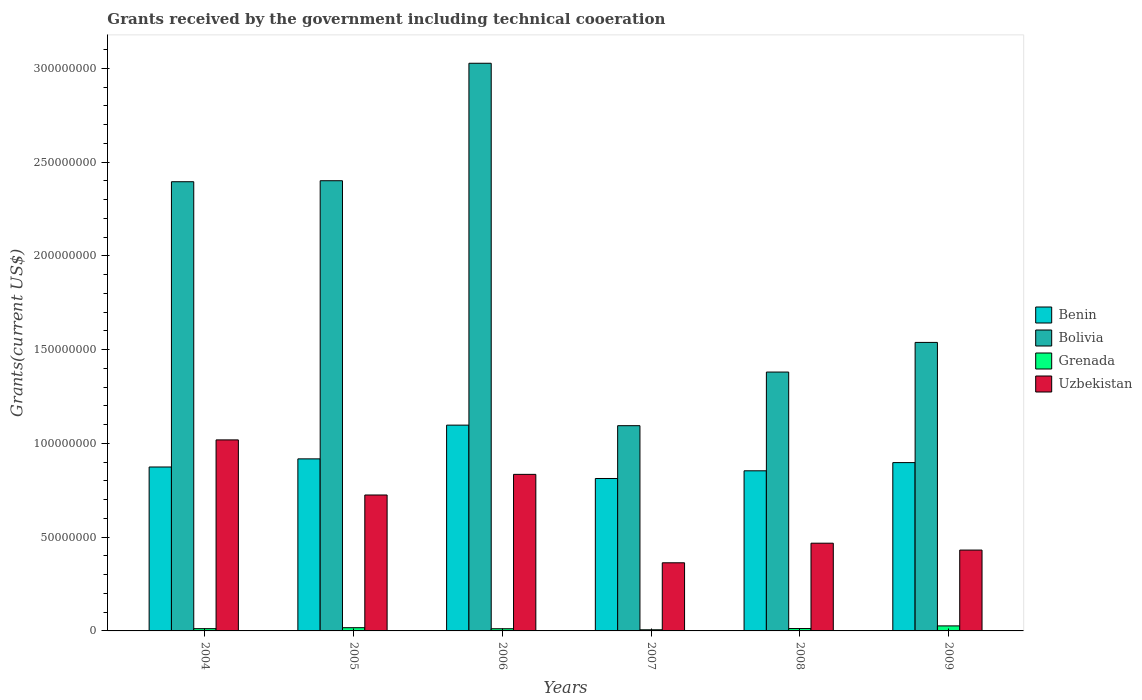Are the number of bars on each tick of the X-axis equal?
Make the answer very short. Yes. What is the label of the 6th group of bars from the left?
Provide a succinct answer. 2009. Across all years, what is the maximum total grants received by the government in Bolivia?
Keep it short and to the point. 3.03e+08. Across all years, what is the minimum total grants received by the government in Bolivia?
Your answer should be very brief. 1.09e+08. In which year was the total grants received by the government in Uzbekistan maximum?
Ensure brevity in your answer.  2004. What is the total total grants received by the government in Bolivia in the graph?
Make the answer very short. 1.18e+09. What is the difference between the total grants received by the government in Bolivia in 2004 and that in 2006?
Offer a very short reply. -6.32e+07. What is the difference between the total grants received by the government in Benin in 2007 and the total grants received by the government in Uzbekistan in 2004?
Your response must be concise. -2.06e+07. What is the average total grants received by the government in Benin per year?
Offer a very short reply. 9.09e+07. In the year 2006, what is the difference between the total grants received by the government in Benin and total grants received by the government in Uzbekistan?
Offer a terse response. 2.62e+07. What is the ratio of the total grants received by the government in Uzbekistan in 2004 to that in 2006?
Ensure brevity in your answer.  1.22. Is the difference between the total grants received by the government in Benin in 2005 and 2009 greater than the difference between the total grants received by the government in Uzbekistan in 2005 and 2009?
Give a very brief answer. No. What is the difference between the highest and the second highest total grants received by the government in Grenada?
Provide a short and direct response. 9.60e+05. What is the difference between the highest and the lowest total grants received by the government in Benin?
Offer a terse response. 2.84e+07. Is the sum of the total grants received by the government in Grenada in 2005 and 2008 greater than the maximum total grants received by the government in Benin across all years?
Keep it short and to the point. No. What does the 1st bar from the left in 2008 represents?
Your answer should be very brief. Benin. What does the 4th bar from the right in 2005 represents?
Offer a very short reply. Benin. Is it the case that in every year, the sum of the total grants received by the government in Uzbekistan and total grants received by the government in Bolivia is greater than the total grants received by the government in Benin?
Make the answer very short. Yes. Are all the bars in the graph horizontal?
Keep it short and to the point. No. Does the graph contain any zero values?
Offer a terse response. No. Does the graph contain grids?
Ensure brevity in your answer.  No. Where does the legend appear in the graph?
Your answer should be very brief. Center right. How are the legend labels stacked?
Offer a terse response. Vertical. What is the title of the graph?
Your answer should be very brief. Grants received by the government including technical cooeration. What is the label or title of the Y-axis?
Offer a very short reply. Grants(current US$). What is the Grants(current US$) of Benin in 2004?
Keep it short and to the point. 8.74e+07. What is the Grants(current US$) in Bolivia in 2004?
Your answer should be compact. 2.40e+08. What is the Grants(current US$) in Grenada in 2004?
Provide a succinct answer. 1.20e+06. What is the Grants(current US$) of Uzbekistan in 2004?
Offer a terse response. 1.02e+08. What is the Grants(current US$) of Benin in 2005?
Provide a succinct answer. 9.17e+07. What is the Grants(current US$) of Bolivia in 2005?
Provide a succinct answer. 2.40e+08. What is the Grants(current US$) of Grenada in 2005?
Your response must be concise. 1.72e+06. What is the Grants(current US$) of Uzbekistan in 2005?
Your answer should be compact. 7.25e+07. What is the Grants(current US$) of Benin in 2006?
Provide a succinct answer. 1.10e+08. What is the Grants(current US$) of Bolivia in 2006?
Your answer should be compact. 3.03e+08. What is the Grants(current US$) in Grenada in 2006?
Your response must be concise. 1.16e+06. What is the Grants(current US$) of Uzbekistan in 2006?
Offer a terse response. 8.35e+07. What is the Grants(current US$) of Benin in 2007?
Your response must be concise. 8.13e+07. What is the Grants(current US$) of Bolivia in 2007?
Your answer should be compact. 1.09e+08. What is the Grants(current US$) in Grenada in 2007?
Your answer should be compact. 6.00e+05. What is the Grants(current US$) in Uzbekistan in 2007?
Give a very brief answer. 3.63e+07. What is the Grants(current US$) of Benin in 2008?
Your response must be concise. 8.54e+07. What is the Grants(current US$) in Bolivia in 2008?
Offer a terse response. 1.38e+08. What is the Grants(current US$) of Grenada in 2008?
Your answer should be very brief. 1.27e+06. What is the Grants(current US$) of Uzbekistan in 2008?
Make the answer very short. 4.68e+07. What is the Grants(current US$) in Benin in 2009?
Your answer should be very brief. 8.98e+07. What is the Grants(current US$) of Bolivia in 2009?
Your answer should be very brief. 1.54e+08. What is the Grants(current US$) of Grenada in 2009?
Offer a very short reply. 2.68e+06. What is the Grants(current US$) in Uzbekistan in 2009?
Your answer should be compact. 4.31e+07. Across all years, what is the maximum Grants(current US$) in Benin?
Your answer should be very brief. 1.10e+08. Across all years, what is the maximum Grants(current US$) in Bolivia?
Keep it short and to the point. 3.03e+08. Across all years, what is the maximum Grants(current US$) of Grenada?
Provide a short and direct response. 2.68e+06. Across all years, what is the maximum Grants(current US$) of Uzbekistan?
Keep it short and to the point. 1.02e+08. Across all years, what is the minimum Grants(current US$) in Benin?
Provide a succinct answer. 8.13e+07. Across all years, what is the minimum Grants(current US$) of Bolivia?
Ensure brevity in your answer.  1.09e+08. Across all years, what is the minimum Grants(current US$) of Grenada?
Make the answer very short. 6.00e+05. Across all years, what is the minimum Grants(current US$) in Uzbekistan?
Give a very brief answer. 3.63e+07. What is the total Grants(current US$) of Benin in the graph?
Make the answer very short. 5.45e+08. What is the total Grants(current US$) in Bolivia in the graph?
Provide a succinct answer. 1.18e+09. What is the total Grants(current US$) of Grenada in the graph?
Your answer should be very brief. 8.63e+06. What is the total Grants(current US$) in Uzbekistan in the graph?
Give a very brief answer. 3.84e+08. What is the difference between the Grants(current US$) of Benin in 2004 and that in 2005?
Give a very brief answer. -4.33e+06. What is the difference between the Grants(current US$) of Bolivia in 2004 and that in 2005?
Provide a short and direct response. -5.30e+05. What is the difference between the Grants(current US$) in Grenada in 2004 and that in 2005?
Give a very brief answer. -5.20e+05. What is the difference between the Grants(current US$) in Uzbekistan in 2004 and that in 2005?
Keep it short and to the point. 2.94e+07. What is the difference between the Grants(current US$) in Benin in 2004 and that in 2006?
Offer a terse response. -2.23e+07. What is the difference between the Grants(current US$) in Bolivia in 2004 and that in 2006?
Provide a short and direct response. -6.32e+07. What is the difference between the Grants(current US$) of Grenada in 2004 and that in 2006?
Offer a very short reply. 4.00e+04. What is the difference between the Grants(current US$) of Uzbekistan in 2004 and that in 2006?
Your answer should be very brief. 1.84e+07. What is the difference between the Grants(current US$) of Benin in 2004 and that in 2007?
Make the answer very short. 6.13e+06. What is the difference between the Grants(current US$) in Bolivia in 2004 and that in 2007?
Provide a succinct answer. 1.30e+08. What is the difference between the Grants(current US$) of Uzbekistan in 2004 and that in 2007?
Keep it short and to the point. 6.55e+07. What is the difference between the Grants(current US$) of Benin in 2004 and that in 2008?
Your answer should be compact. 2.03e+06. What is the difference between the Grants(current US$) of Bolivia in 2004 and that in 2008?
Make the answer very short. 1.01e+08. What is the difference between the Grants(current US$) of Grenada in 2004 and that in 2008?
Keep it short and to the point. -7.00e+04. What is the difference between the Grants(current US$) of Uzbekistan in 2004 and that in 2008?
Offer a very short reply. 5.51e+07. What is the difference between the Grants(current US$) in Benin in 2004 and that in 2009?
Provide a short and direct response. -2.34e+06. What is the difference between the Grants(current US$) in Bolivia in 2004 and that in 2009?
Provide a short and direct response. 8.57e+07. What is the difference between the Grants(current US$) of Grenada in 2004 and that in 2009?
Offer a very short reply. -1.48e+06. What is the difference between the Grants(current US$) of Uzbekistan in 2004 and that in 2009?
Ensure brevity in your answer.  5.88e+07. What is the difference between the Grants(current US$) of Benin in 2005 and that in 2006?
Make the answer very short. -1.80e+07. What is the difference between the Grants(current US$) in Bolivia in 2005 and that in 2006?
Provide a succinct answer. -6.26e+07. What is the difference between the Grants(current US$) of Grenada in 2005 and that in 2006?
Give a very brief answer. 5.60e+05. What is the difference between the Grants(current US$) of Uzbekistan in 2005 and that in 2006?
Provide a succinct answer. -1.10e+07. What is the difference between the Grants(current US$) in Benin in 2005 and that in 2007?
Provide a succinct answer. 1.05e+07. What is the difference between the Grants(current US$) in Bolivia in 2005 and that in 2007?
Your answer should be compact. 1.31e+08. What is the difference between the Grants(current US$) in Grenada in 2005 and that in 2007?
Keep it short and to the point. 1.12e+06. What is the difference between the Grants(current US$) in Uzbekistan in 2005 and that in 2007?
Make the answer very short. 3.62e+07. What is the difference between the Grants(current US$) in Benin in 2005 and that in 2008?
Offer a terse response. 6.36e+06. What is the difference between the Grants(current US$) of Bolivia in 2005 and that in 2008?
Make the answer very short. 1.02e+08. What is the difference between the Grants(current US$) of Grenada in 2005 and that in 2008?
Ensure brevity in your answer.  4.50e+05. What is the difference between the Grants(current US$) of Uzbekistan in 2005 and that in 2008?
Provide a short and direct response. 2.57e+07. What is the difference between the Grants(current US$) in Benin in 2005 and that in 2009?
Offer a terse response. 1.99e+06. What is the difference between the Grants(current US$) of Bolivia in 2005 and that in 2009?
Give a very brief answer. 8.62e+07. What is the difference between the Grants(current US$) in Grenada in 2005 and that in 2009?
Your answer should be very brief. -9.60e+05. What is the difference between the Grants(current US$) of Uzbekistan in 2005 and that in 2009?
Your answer should be compact. 2.94e+07. What is the difference between the Grants(current US$) in Benin in 2006 and that in 2007?
Ensure brevity in your answer.  2.84e+07. What is the difference between the Grants(current US$) of Bolivia in 2006 and that in 2007?
Offer a very short reply. 1.93e+08. What is the difference between the Grants(current US$) of Grenada in 2006 and that in 2007?
Your response must be concise. 5.60e+05. What is the difference between the Grants(current US$) of Uzbekistan in 2006 and that in 2007?
Give a very brief answer. 4.72e+07. What is the difference between the Grants(current US$) of Benin in 2006 and that in 2008?
Provide a short and direct response. 2.44e+07. What is the difference between the Grants(current US$) in Bolivia in 2006 and that in 2008?
Offer a very short reply. 1.65e+08. What is the difference between the Grants(current US$) of Uzbekistan in 2006 and that in 2008?
Your response must be concise. 3.67e+07. What is the difference between the Grants(current US$) in Benin in 2006 and that in 2009?
Your response must be concise. 2.00e+07. What is the difference between the Grants(current US$) of Bolivia in 2006 and that in 2009?
Ensure brevity in your answer.  1.49e+08. What is the difference between the Grants(current US$) in Grenada in 2006 and that in 2009?
Give a very brief answer. -1.52e+06. What is the difference between the Grants(current US$) in Uzbekistan in 2006 and that in 2009?
Give a very brief answer. 4.04e+07. What is the difference between the Grants(current US$) of Benin in 2007 and that in 2008?
Your response must be concise. -4.10e+06. What is the difference between the Grants(current US$) of Bolivia in 2007 and that in 2008?
Offer a very short reply. -2.86e+07. What is the difference between the Grants(current US$) of Grenada in 2007 and that in 2008?
Your answer should be very brief. -6.70e+05. What is the difference between the Grants(current US$) of Uzbekistan in 2007 and that in 2008?
Offer a terse response. -1.04e+07. What is the difference between the Grants(current US$) in Benin in 2007 and that in 2009?
Provide a short and direct response. -8.47e+06. What is the difference between the Grants(current US$) of Bolivia in 2007 and that in 2009?
Keep it short and to the point. -4.44e+07. What is the difference between the Grants(current US$) in Grenada in 2007 and that in 2009?
Offer a very short reply. -2.08e+06. What is the difference between the Grants(current US$) in Uzbekistan in 2007 and that in 2009?
Your response must be concise. -6.78e+06. What is the difference between the Grants(current US$) in Benin in 2008 and that in 2009?
Provide a short and direct response. -4.37e+06. What is the difference between the Grants(current US$) of Bolivia in 2008 and that in 2009?
Offer a very short reply. -1.58e+07. What is the difference between the Grants(current US$) of Grenada in 2008 and that in 2009?
Your answer should be very brief. -1.41e+06. What is the difference between the Grants(current US$) of Uzbekistan in 2008 and that in 2009?
Offer a terse response. 3.67e+06. What is the difference between the Grants(current US$) in Benin in 2004 and the Grants(current US$) in Bolivia in 2005?
Ensure brevity in your answer.  -1.53e+08. What is the difference between the Grants(current US$) in Benin in 2004 and the Grants(current US$) in Grenada in 2005?
Keep it short and to the point. 8.57e+07. What is the difference between the Grants(current US$) of Benin in 2004 and the Grants(current US$) of Uzbekistan in 2005?
Offer a terse response. 1.49e+07. What is the difference between the Grants(current US$) in Bolivia in 2004 and the Grants(current US$) in Grenada in 2005?
Your answer should be very brief. 2.38e+08. What is the difference between the Grants(current US$) of Bolivia in 2004 and the Grants(current US$) of Uzbekistan in 2005?
Provide a succinct answer. 1.67e+08. What is the difference between the Grants(current US$) of Grenada in 2004 and the Grants(current US$) of Uzbekistan in 2005?
Your answer should be very brief. -7.13e+07. What is the difference between the Grants(current US$) in Benin in 2004 and the Grants(current US$) in Bolivia in 2006?
Ensure brevity in your answer.  -2.15e+08. What is the difference between the Grants(current US$) in Benin in 2004 and the Grants(current US$) in Grenada in 2006?
Provide a succinct answer. 8.62e+07. What is the difference between the Grants(current US$) of Benin in 2004 and the Grants(current US$) of Uzbekistan in 2006?
Offer a very short reply. 3.93e+06. What is the difference between the Grants(current US$) in Bolivia in 2004 and the Grants(current US$) in Grenada in 2006?
Offer a terse response. 2.38e+08. What is the difference between the Grants(current US$) of Bolivia in 2004 and the Grants(current US$) of Uzbekistan in 2006?
Provide a short and direct response. 1.56e+08. What is the difference between the Grants(current US$) in Grenada in 2004 and the Grants(current US$) in Uzbekistan in 2006?
Your answer should be very brief. -8.23e+07. What is the difference between the Grants(current US$) in Benin in 2004 and the Grants(current US$) in Bolivia in 2007?
Your response must be concise. -2.20e+07. What is the difference between the Grants(current US$) of Benin in 2004 and the Grants(current US$) of Grenada in 2007?
Offer a terse response. 8.68e+07. What is the difference between the Grants(current US$) in Benin in 2004 and the Grants(current US$) in Uzbekistan in 2007?
Give a very brief answer. 5.11e+07. What is the difference between the Grants(current US$) of Bolivia in 2004 and the Grants(current US$) of Grenada in 2007?
Your answer should be very brief. 2.39e+08. What is the difference between the Grants(current US$) of Bolivia in 2004 and the Grants(current US$) of Uzbekistan in 2007?
Provide a succinct answer. 2.03e+08. What is the difference between the Grants(current US$) in Grenada in 2004 and the Grants(current US$) in Uzbekistan in 2007?
Your response must be concise. -3.51e+07. What is the difference between the Grants(current US$) in Benin in 2004 and the Grants(current US$) in Bolivia in 2008?
Offer a very short reply. -5.06e+07. What is the difference between the Grants(current US$) in Benin in 2004 and the Grants(current US$) in Grenada in 2008?
Make the answer very short. 8.61e+07. What is the difference between the Grants(current US$) in Benin in 2004 and the Grants(current US$) in Uzbekistan in 2008?
Offer a terse response. 4.06e+07. What is the difference between the Grants(current US$) of Bolivia in 2004 and the Grants(current US$) of Grenada in 2008?
Your response must be concise. 2.38e+08. What is the difference between the Grants(current US$) of Bolivia in 2004 and the Grants(current US$) of Uzbekistan in 2008?
Provide a succinct answer. 1.93e+08. What is the difference between the Grants(current US$) of Grenada in 2004 and the Grants(current US$) of Uzbekistan in 2008?
Offer a very short reply. -4.56e+07. What is the difference between the Grants(current US$) of Benin in 2004 and the Grants(current US$) of Bolivia in 2009?
Offer a terse response. -6.64e+07. What is the difference between the Grants(current US$) in Benin in 2004 and the Grants(current US$) in Grenada in 2009?
Your response must be concise. 8.47e+07. What is the difference between the Grants(current US$) in Benin in 2004 and the Grants(current US$) in Uzbekistan in 2009?
Provide a short and direct response. 4.43e+07. What is the difference between the Grants(current US$) in Bolivia in 2004 and the Grants(current US$) in Grenada in 2009?
Provide a short and direct response. 2.37e+08. What is the difference between the Grants(current US$) of Bolivia in 2004 and the Grants(current US$) of Uzbekistan in 2009?
Your answer should be very brief. 1.96e+08. What is the difference between the Grants(current US$) in Grenada in 2004 and the Grants(current US$) in Uzbekistan in 2009?
Provide a short and direct response. -4.19e+07. What is the difference between the Grants(current US$) of Benin in 2005 and the Grants(current US$) of Bolivia in 2006?
Your response must be concise. -2.11e+08. What is the difference between the Grants(current US$) of Benin in 2005 and the Grants(current US$) of Grenada in 2006?
Keep it short and to the point. 9.06e+07. What is the difference between the Grants(current US$) of Benin in 2005 and the Grants(current US$) of Uzbekistan in 2006?
Ensure brevity in your answer.  8.26e+06. What is the difference between the Grants(current US$) in Bolivia in 2005 and the Grants(current US$) in Grenada in 2006?
Keep it short and to the point. 2.39e+08. What is the difference between the Grants(current US$) of Bolivia in 2005 and the Grants(current US$) of Uzbekistan in 2006?
Your response must be concise. 1.57e+08. What is the difference between the Grants(current US$) of Grenada in 2005 and the Grants(current US$) of Uzbekistan in 2006?
Keep it short and to the point. -8.18e+07. What is the difference between the Grants(current US$) of Benin in 2005 and the Grants(current US$) of Bolivia in 2007?
Offer a terse response. -1.77e+07. What is the difference between the Grants(current US$) of Benin in 2005 and the Grants(current US$) of Grenada in 2007?
Make the answer very short. 9.11e+07. What is the difference between the Grants(current US$) in Benin in 2005 and the Grants(current US$) in Uzbekistan in 2007?
Ensure brevity in your answer.  5.54e+07. What is the difference between the Grants(current US$) of Bolivia in 2005 and the Grants(current US$) of Grenada in 2007?
Your answer should be very brief. 2.39e+08. What is the difference between the Grants(current US$) in Bolivia in 2005 and the Grants(current US$) in Uzbekistan in 2007?
Make the answer very short. 2.04e+08. What is the difference between the Grants(current US$) of Grenada in 2005 and the Grants(current US$) of Uzbekistan in 2007?
Your response must be concise. -3.46e+07. What is the difference between the Grants(current US$) in Benin in 2005 and the Grants(current US$) in Bolivia in 2008?
Ensure brevity in your answer.  -4.63e+07. What is the difference between the Grants(current US$) in Benin in 2005 and the Grants(current US$) in Grenada in 2008?
Offer a terse response. 9.05e+07. What is the difference between the Grants(current US$) of Benin in 2005 and the Grants(current US$) of Uzbekistan in 2008?
Give a very brief answer. 4.50e+07. What is the difference between the Grants(current US$) in Bolivia in 2005 and the Grants(current US$) in Grenada in 2008?
Your answer should be compact. 2.39e+08. What is the difference between the Grants(current US$) of Bolivia in 2005 and the Grants(current US$) of Uzbekistan in 2008?
Your answer should be compact. 1.93e+08. What is the difference between the Grants(current US$) of Grenada in 2005 and the Grants(current US$) of Uzbekistan in 2008?
Your answer should be compact. -4.51e+07. What is the difference between the Grants(current US$) of Benin in 2005 and the Grants(current US$) of Bolivia in 2009?
Offer a very short reply. -6.21e+07. What is the difference between the Grants(current US$) of Benin in 2005 and the Grants(current US$) of Grenada in 2009?
Provide a succinct answer. 8.91e+07. What is the difference between the Grants(current US$) of Benin in 2005 and the Grants(current US$) of Uzbekistan in 2009?
Keep it short and to the point. 4.86e+07. What is the difference between the Grants(current US$) in Bolivia in 2005 and the Grants(current US$) in Grenada in 2009?
Your answer should be very brief. 2.37e+08. What is the difference between the Grants(current US$) in Bolivia in 2005 and the Grants(current US$) in Uzbekistan in 2009?
Ensure brevity in your answer.  1.97e+08. What is the difference between the Grants(current US$) of Grenada in 2005 and the Grants(current US$) of Uzbekistan in 2009?
Provide a succinct answer. -4.14e+07. What is the difference between the Grants(current US$) in Benin in 2006 and the Grants(current US$) in Bolivia in 2007?
Your answer should be very brief. 2.90e+05. What is the difference between the Grants(current US$) of Benin in 2006 and the Grants(current US$) of Grenada in 2007?
Offer a terse response. 1.09e+08. What is the difference between the Grants(current US$) in Benin in 2006 and the Grants(current US$) in Uzbekistan in 2007?
Your response must be concise. 7.34e+07. What is the difference between the Grants(current US$) of Bolivia in 2006 and the Grants(current US$) of Grenada in 2007?
Your answer should be compact. 3.02e+08. What is the difference between the Grants(current US$) of Bolivia in 2006 and the Grants(current US$) of Uzbekistan in 2007?
Ensure brevity in your answer.  2.66e+08. What is the difference between the Grants(current US$) of Grenada in 2006 and the Grants(current US$) of Uzbekistan in 2007?
Offer a terse response. -3.52e+07. What is the difference between the Grants(current US$) of Benin in 2006 and the Grants(current US$) of Bolivia in 2008?
Provide a succinct answer. -2.83e+07. What is the difference between the Grants(current US$) of Benin in 2006 and the Grants(current US$) of Grenada in 2008?
Make the answer very short. 1.08e+08. What is the difference between the Grants(current US$) in Benin in 2006 and the Grants(current US$) in Uzbekistan in 2008?
Give a very brief answer. 6.30e+07. What is the difference between the Grants(current US$) of Bolivia in 2006 and the Grants(current US$) of Grenada in 2008?
Your answer should be very brief. 3.01e+08. What is the difference between the Grants(current US$) in Bolivia in 2006 and the Grants(current US$) in Uzbekistan in 2008?
Provide a short and direct response. 2.56e+08. What is the difference between the Grants(current US$) in Grenada in 2006 and the Grants(current US$) in Uzbekistan in 2008?
Provide a short and direct response. -4.56e+07. What is the difference between the Grants(current US$) of Benin in 2006 and the Grants(current US$) of Bolivia in 2009?
Your response must be concise. -4.41e+07. What is the difference between the Grants(current US$) of Benin in 2006 and the Grants(current US$) of Grenada in 2009?
Keep it short and to the point. 1.07e+08. What is the difference between the Grants(current US$) of Benin in 2006 and the Grants(current US$) of Uzbekistan in 2009?
Your answer should be very brief. 6.66e+07. What is the difference between the Grants(current US$) of Bolivia in 2006 and the Grants(current US$) of Grenada in 2009?
Offer a very short reply. 3.00e+08. What is the difference between the Grants(current US$) in Bolivia in 2006 and the Grants(current US$) in Uzbekistan in 2009?
Make the answer very short. 2.60e+08. What is the difference between the Grants(current US$) in Grenada in 2006 and the Grants(current US$) in Uzbekistan in 2009?
Give a very brief answer. -4.20e+07. What is the difference between the Grants(current US$) of Benin in 2007 and the Grants(current US$) of Bolivia in 2008?
Your response must be concise. -5.68e+07. What is the difference between the Grants(current US$) in Benin in 2007 and the Grants(current US$) in Grenada in 2008?
Your answer should be very brief. 8.00e+07. What is the difference between the Grants(current US$) in Benin in 2007 and the Grants(current US$) in Uzbekistan in 2008?
Make the answer very short. 3.45e+07. What is the difference between the Grants(current US$) in Bolivia in 2007 and the Grants(current US$) in Grenada in 2008?
Make the answer very short. 1.08e+08. What is the difference between the Grants(current US$) in Bolivia in 2007 and the Grants(current US$) in Uzbekistan in 2008?
Keep it short and to the point. 6.27e+07. What is the difference between the Grants(current US$) in Grenada in 2007 and the Grants(current US$) in Uzbekistan in 2008?
Provide a short and direct response. -4.62e+07. What is the difference between the Grants(current US$) of Benin in 2007 and the Grants(current US$) of Bolivia in 2009?
Offer a very short reply. -7.26e+07. What is the difference between the Grants(current US$) in Benin in 2007 and the Grants(current US$) in Grenada in 2009?
Keep it short and to the point. 7.86e+07. What is the difference between the Grants(current US$) in Benin in 2007 and the Grants(current US$) in Uzbekistan in 2009?
Offer a very short reply. 3.82e+07. What is the difference between the Grants(current US$) of Bolivia in 2007 and the Grants(current US$) of Grenada in 2009?
Your response must be concise. 1.07e+08. What is the difference between the Grants(current US$) of Bolivia in 2007 and the Grants(current US$) of Uzbekistan in 2009?
Keep it short and to the point. 6.63e+07. What is the difference between the Grants(current US$) of Grenada in 2007 and the Grants(current US$) of Uzbekistan in 2009?
Your answer should be compact. -4.25e+07. What is the difference between the Grants(current US$) in Benin in 2008 and the Grants(current US$) in Bolivia in 2009?
Your answer should be compact. -6.85e+07. What is the difference between the Grants(current US$) in Benin in 2008 and the Grants(current US$) in Grenada in 2009?
Provide a succinct answer. 8.27e+07. What is the difference between the Grants(current US$) of Benin in 2008 and the Grants(current US$) of Uzbekistan in 2009?
Keep it short and to the point. 4.23e+07. What is the difference between the Grants(current US$) in Bolivia in 2008 and the Grants(current US$) in Grenada in 2009?
Offer a terse response. 1.35e+08. What is the difference between the Grants(current US$) of Bolivia in 2008 and the Grants(current US$) of Uzbekistan in 2009?
Make the answer very short. 9.49e+07. What is the difference between the Grants(current US$) in Grenada in 2008 and the Grants(current US$) in Uzbekistan in 2009?
Your answer should be compact. -4.18e+07. What is the average Grants(current US$) in Benin per year?
Keep it short and to the point. 9.09e+07. What is the average Grants(current US$) in Bolivia per year?
Your response must be concise. 1.97e+08. What is the average Grants(current US$) in Grenada per year?
Your response must be concise. 1.44e+06. What is the average Grants(current US$) in Uzbekistan per year?
Ensure brevity in your answer.  6.40e+07. In the year 2004, what is the difference between the Grants(current US$) in Benin and Grants(current US$) in Bolivia?
Your answer should be very brief. -1.52e+08. In the year 2004, what is the difference between the Grants(current US$) of Benin and Grants(current US$) of Grenada?
Keep it short and to the point. 8.62e+07. In the year 2004, what is the difference between the Grants(current US$) of Benin and Grants(current US$) of Uzbekistan?
Provide a short and direct response. -1.44e+07. In the year 2004, what is the difference between the Grants(current US$) of Bolivia and Grants(current US$) of Grenada?
Ensure brevity in your answer.  2.38e+08. In the year 2004, what is the difference between the Grants(current US$) of Bolivia and Grants(current US$) of Uzbekistan?
Provide a succinct answer. 1.38e+08. In the year 2004, what is the difference between the Grants(current US$) in Grenada and Grants(current US$) in Uzbekistan?
Give a very brief answer. -1.01e+08. In the year 2005, what is the difference between the Grants(current US$) of Benin and Grants(current US$) of Bolivia?
Offer a terse response. -1.48e+08. In the year 2005, what is the difference between the Grants(current US$) of Benin and Grants(current US$) of Grenada?
Offer a terse response. 9.00e+07. In the year 2005, what is the difference between the Grants(current US$) in Benin and Grants(current US$) in Uzbekistan?
Provide a short and direct response. 1.93e+07. In the year 2005, what is the difference between the Grants(current US$) of Bolivia and Grants(current US$) of Grenada?
Ensure brevity in your answer.  2.38e+08. In the year 2005, what is the difference between the Grants(current US$) of Bolivia and Grants(current US$) of Uzbekistan?
Provide a succinct answer. 1.68e+08. In the year 2005, what is the difference between the Grants(current US$) of Grenada and Grants(current US$) of Uzbekistan?
Your answer should be very brief. -7.08e+07. In the year 2006, what is the difference between the Grants(current US$) in Benin and Grants(current US$) in Bolivia?
Provide a short and direct response. -1.93e+08. In the year 2006, what is the difference between the Grants(current US$) of Benin and Grants(current US$) of Grenada?
Offer a very short reply. 1.09e+08. In the year 2006, what is the difference between the Grants(current US$) in Benin and Grants(current US$) in Uzbekistan?
Give a very brief answer. 2.62e+07. In the year 2006, what is the difference between the Grants(current US$) in Bolivia and Grants(current US$) in Grenada?
Offer a very short reply. 3.02e+08. In the year 2006, what is the difference between the Grants(current US$) of Bolivia and Grants(current US$) of Uzbekistan?
Your response must be concise. 2.19e+08. In the year 2006, what is the difference between the Grants(current US$) in Grenada and Grants(current US$) in Uzbekistan?
Provide a short and direct response. -8.23e+07. In the year 2007, what is the difference between the Grants(current US$) of Benin and Grants(current US$) of Bolivia?
Offer a terse response. -2.82e+07. In the year 2007, what is the difference between the Grants(current US$) of Benin and Grants(current US$) of Grenada?
Keep it short and to the point. 8.07e+07. In the year 2007, what is the difference between the Grants(current US$) in Benin and Grants(current US$) in Uzbekistan?
Keep it short and to the point. 4.50e+07. In the year 2007, what is the difference between the Grants(current US$) in Bolivia and Grants(current US$) in Grenada?
Your response must be concise. 1.09e+08. In the year 2007, what is the difference between the Grants(current US$) in Bolivia and Grants(current US$) in Uzbekistan?
Provide a succinct answer. 7.31e+07. In the year 2007, what is the difference between the Grants(current US$) in Grenada and Grants(current US$) in Uzbekistan?
Provide a short and direct response. -3.57e+07. In the year 2008, what is the difference between the Grants(current US$) in Benin and Grants(current US$) in Bolivia?
Give a very brief answer. -5.26e+07. In the year 2008, what is the difference between the Grants(current US$) of Benin and Grants(current US$) of Grenada?
Provide a short and direct response. 8.41e+07. In the year 2008, what is the difference between the Grants(current US$) of Benin and Grants(current US$) of Uzbekistan?
Provide a short and direct response. 3.86e+07. In the year 2008, what is the difference between the Grants(current US$) of Bolivia and Grants(current US$) of Grenada?
Your answer should be very brief. 1.37e+08. In the year 2008, what is the difference between the Grants(current US$) in Bolivia and Grants(current US$) in Uzbekistan?
Provide a short and direct response. 9.12e+07. In the year 2008, what is the difference between the Grants(current US$) of Grenada and Grants(current US$) of Uzbekistan?
Provide a short and direct response. -4.55e+07. In the year 2009, what is the difference between the Grants(current US$) of Benin and Grants(current US$) of Bolivia?
Keep it short and to the point. -6.41e+07. In the year 2009, what is the difference between the Grants(current US$) of Benin and Grants(current US$) of Grenada?
Offer a very short reply. 8.71e+07. In the year 2009, what is the difference between the Grants(current US$) in Benin and Grants(current US$) in Uzbekistan?
Offer a terse response. 4.66e+07. In the year 2009, what is the difference between the Grants(current US$) in Bolivia and Grants(current US$) in Grenada?
Provide a short and direct response. 1.51e+08. In the year 2009, what is the difference between the Grants(current US$) in Bolivia and Grants(current US$) in Uzbekistan?
Give a very brief answer. 1.11e+08. In the year 2009, what is the difference between the Grants(current US$) in Grenada and Grants(current US$) in Uzbekistan?
Offer a very short reply. -4.04e+07. What is the ratio of the Grants(current US$) of Benin in 2004 to that in 2005?
Provide a short and direct response. 0.95. What is the ratio of the Grants(current US$) in Grenada in 2004 to that in 2005?
Offer a very short reply. 0.7. What is the ratio of the Grants(current US$) in Uzbekistan in 2004 to that in 2005?
Your answer should be compact. 1.41. What is the ratio of the Grants(current US$) of Benin in 2004 to that in 2006?
Provide a short and direct response. 0.8. What is the ratio of the Grants(current US$) of Bolivia in 2004 to that in 2006?
Your answer should be very brief. 0.79. What is the ratio of the Grants(current US$) of Grenada in 2004 to that in 2006?
Offer a very short reply. 1.03. What is the ratio of the Grants(current US$) of Uzbekistan in 2004 to that in 2006?
Your response must be concise. 1.22. What is the ratio of the Grants(current US$) of Benin in 2004 to that in 2007?
Give a very brief answer. 1.08. What is the ratio of the Grants(current US$) of Bolivia in 2004 to that in 2007?
Offer a very short reply. 2.19. What is the ratio of the Grants(current US$) of Uzbekistan in 2004 to that in 2007?
Keep it short and to the point. 2.8. What is the ratio of the Grants(current US$) of Benin in 2004 to that in 2008?
Give a very brief answer. 1.02. What is the ratio of the Grants(current US$) in Bolivia in 2004 to that in 2008?
Your response must be concise. 1.74. What is the ratio of the Grants(current US$) of Grenada in 2004 to that in 2008?
Your response must be concise. 0.94. What is the ratio of the Grants(current US$) of Uzbekistan in 2004 to that in 2008?
Your answer should be very brief. 2.18. What is the ratio of the Grants(current US$) in Benin in 2004 to that in 2009?
Offer a terse response. 0.97. What is the ratio of the Grants(current US$) in Bolivia in 2004 to that in 2009?
Give a very brief answer. 1.56. What is the ratio of the Grants(current US$) in Grenada in 2004 to that in 2009?
Provide a succinct answer. 0.45. What is the ratio of the Grants(current US$) in Uzbekistan in 2004 to that in 2009?
Keep it short and to the point. 2.36. What is the ratio of the Grants(current US$) in Benin in 2005 to that in 2006?
Provide a short and direct response. 0.84. What is the ratio of the Grants(current US$) of Bolivia in 2005 to that in 2006?
Provide a short and direct response. 0.79. What is the ratio of the Grants(current US$) in Grenada in 2005 to that in 2006?
Your answer should be compact. 1.48. What is the ratio of the Grants(current US$) of Uzbekistan in 2005 to that in 2006?
Your answer should be very brief. 0.87. What is the ratio of the Grants(current US$) of Benin in 2005 to that in 2007?
Offer a terse response. 1.13. What is the ratio of the Grants(current US$) in Bolivia in 2005 to that in 2007?
Your answer should be very brief. 2.19. What is the ratio of the Grants(current US$) in Grenada in 2005 to that in 2007?
Give a very brief answer. 2.87. What is the ratio of the Grants(current US$) of Uzbekistan in 2005 to that in 2007?
Give a very brief answer. 2. What is the ratio of the Grants(current US$) of Benin in 2005 to that in 2008?
Your answer should be compact. 1.07. What is the ratio of the Grants(current US$) in Bolivia in 2005 to that in 2008?
Offer a terse response. 1.74. What is the ratio of the Grants(current US$) in Grenada in 2005 to that in 2008?
Keep it short and to the point. 1.35. What is the ratio of the Grants(current US$) of Uzbekistan in 2005 to that in 2008?
Ensure brevity in your answer.  1.55. What is the ratio of the Grants(current US$) in Benin in 2005 to that in 2009?
Offer a very short reply. 1.02. What is the ratio of the Grants(current US$) in Bolivia in 2005 to that in 2009?
Your response must be concise. 1.56. What is the ratio of the Grants(current US$) in Grenada in 2005 to that in 2009?
Provide a short and direct response. 0.64. What is the ratio of the Grants(current US$) of Uzbekistan in 2005 to that in 2009?
Provide a short and direct response. 1.68. What is the ratio of the Grants(current US$) in Benin in 2006 to that in 2007?
Offer a terse response. 1.35. What is the ratio of the Grants(current US$) of Bolivia in 2006 to that in 2007?
Offer a terse response. 2.77. What is the ratio of the Grants(current US$) in Grenada in 2006 to that in 2007?
Give a very brief answer. 1.93. What is the ratio of the Grants(current US$) of Uzbekistan in 2006 to that in 2007?
Your answer should be very brief. 2.3. What is the ratio of the Grants(current US$) of Benin in 2006 to that in 2008?
Your answer should be very brief. 1.29. What is the ratio of the Grants(current US$) in Bolivia in 2006 to that in 2008?
Your answer should be compact. 2.19. What is the ratio of the Grants(current US$) of Grenada in 2006 to that in 2008?
Your response must be concise. 0.91. What is the ratio of the Grants(current US$) in Uzbekistan in 2006 to that in 2008?
Offer a very short reply. 1.78. What is the ratio of the Grants(current US$) of Benin in 2006 to that in 2009?
Offer a very short reply. 1.22. What is the ratio of the Grants(current US$) of Bolivia in 2006 to that in 2009?
Your answer should be very brief. 1.97. What is the ratio of the Grants(current US$) in Grenada in 2006 to that in 2009?
Make the answer very short. 0.43. What is the ratio of the Grants(current US$) in Uzbekistan in 2006 to that in 2009?
Provide a succinct answer. 1.94. What is the ratio of the Grants(current US$) in Bolivia in 2007 to that in 2008?
Make the answer very short. 0.79. What is the ratio of the Grants(current US$) in Grenada in 2007 to that in 2008?
Make the answer very short. 0.47. What is the ratio of the Grants(current US$) of Uzbekistan in 2007 to that in 2008?
Your answer should be very brief. 0.78. What is the ratio of the Grants(current US$) in Benin in 2007 to that in 2009?
Offer a very short reply. 0.91. What is the ratio of the Grants(current US$) of Bolivia in 2007 to that in 2009?
Your response must be concise. 0.71. What is the ratio of the Grants(current US$) of Grenada in 2007 to that in 2009?
Ensure brevity in your answer.  0.22. What is the ratio of the Grants(current US$) in Uzbekistan in 2007 to that in 2009?
Offer a very short reply. 0.84. What is the ratio of the Grants(current US$) of Benin in 2008 to that in 2009?
Ensure brevity in your answer.  0.95. What is the ratio of the Grants(current US$) of Bolivia in 2008 to that in 2009?
Offer a terse response. 0.9. What is the ratio of the Grants(current US$) in Grenada in 2008 to that in 2009?
Your response must be concise. 0.47. What is the ratio of the Grants(current US$) in Uzbekistan in 2008 to that in 2009?
Ensure brevity in your answer.  1.09. What is the difference between the highest and the second highest Grants(current US$) of Benin?
Keep it short and to the point. 1.80e+07. What is the difference between the highest and the second highest Grants(current US$) of Bolivia?
Your answer should be compact. 6.26e+07. What is the difference between the highest and the second highest Grants(current US$) in Grenada?
Provide a short and direct response. 9.60e+05. What is the difference between the highest and the second highest Grants(current US$) of Uzbekistan?
Give a very brief answer. 1.84e+07. What is the difference between the highest and the lowest Grants(current US$) of Benin?
Keep it short and to the point. 2.84e+07. What is the difference between the highest and the lowest Grants(current US$) in Bolivia?
Ensure brevity in your answer.  1.93e+08. What is the difference between the highest and the lowest Grants(current US$) of Grenada?
Your answer should be compact. 2.08e+06. What is the difference between the highest and the lowest Grants(current US$) of Uzbekistan?
Give a very brief answer. 6.55e+07. 